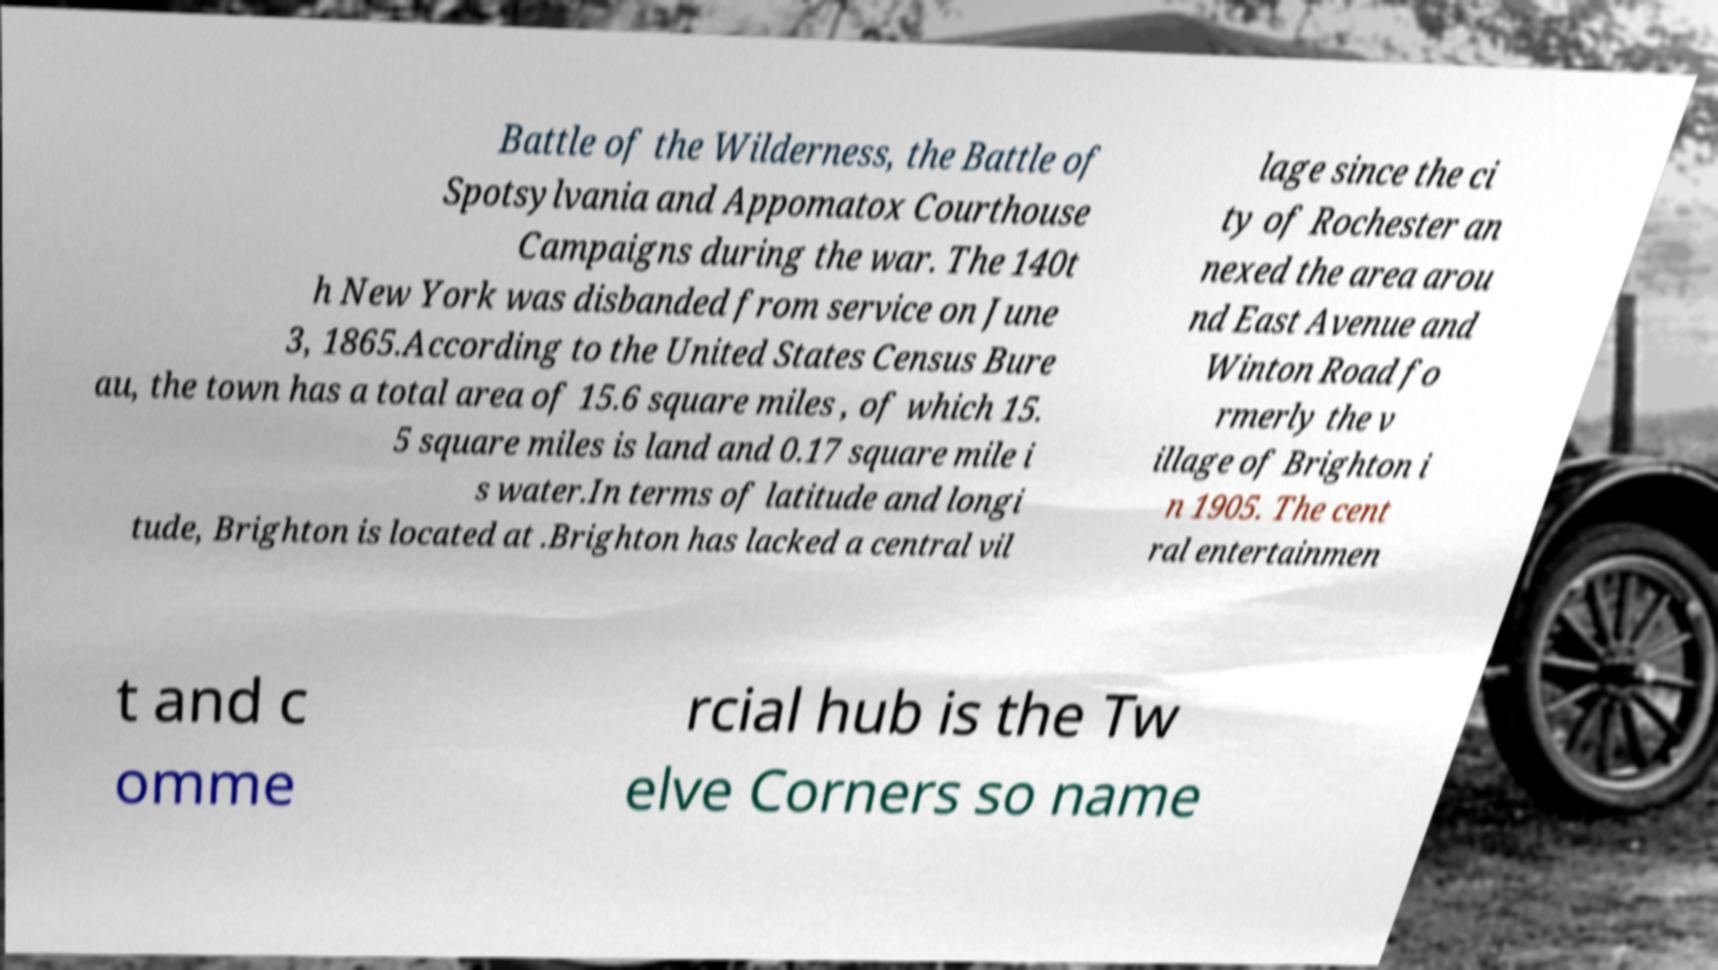Could you assist in decoding the text presented in this image and type it out clearly? Battle of the Wilderness, the Battle of Spotsylvania and Appomatox Courthouse Campaigns during the war. The 140t h New York was disbanded from service on June 3, 1865.According to the United States Census Bure au, the town has a total area of 15.6 square miles , of which 15. 5 square miles is land and 0.17 square mile i s water.In terms of latitude and longi tude, Brighton is located at .Brighton has lacked a central vil lage since the ci ty of Rochester an nexed the area arou nd East Avenue and Winton Road fo rmerly the v illage of Brighton i n 1905. The cent ral entertainmen t and c omme rcial hub is the Tw elve Corners so name 